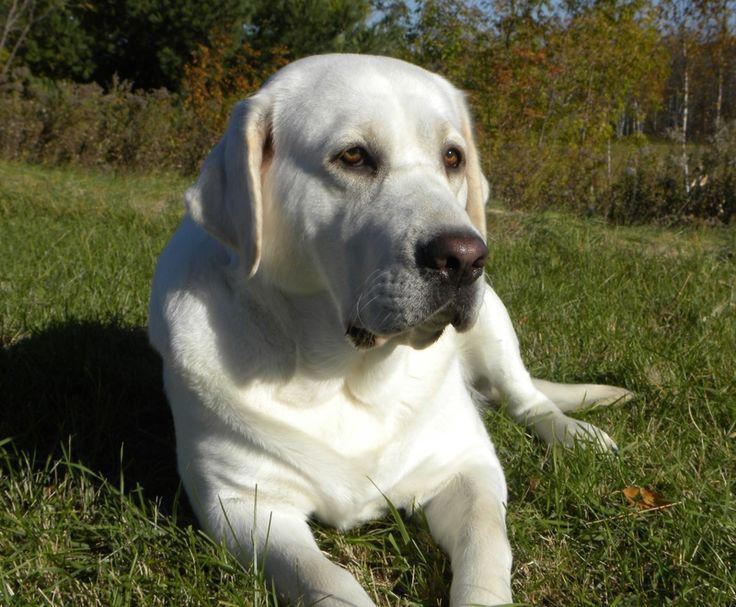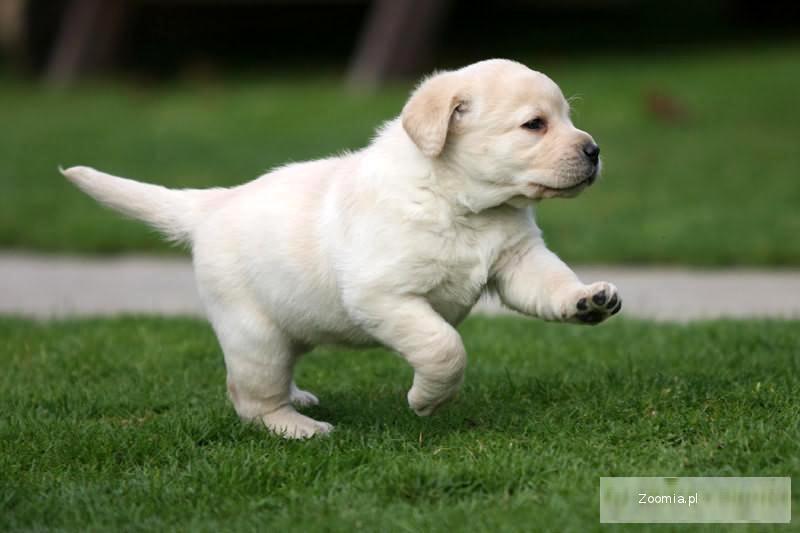The first image is the image on the left, the second image is the image on the right. Considering the images on both sides, is "An image contains exactly two dogs." valid? Answer yes or no. No. The first image is the image on the left, the second image is the image on the right. For the images shown, is this caption "There are three dogs in total." true? Answer yes or no. No. 